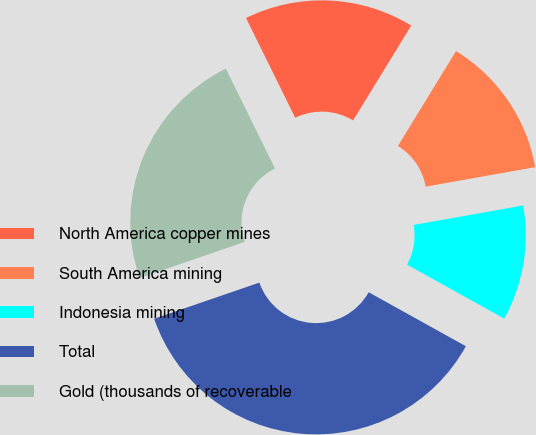Convert chart. <chart><loc_0><loc_0><loc_500><loc_500><pie_chart><fcel>North America copper mines<fcel>South America mining<fcel>Indonesia mining<fcel>Total<fcel>Gold (thousands of recoverable<nl><fcel>16.03%<fcel>13.45%<fcel>10.87%<fcel>36.66%<fcel>22.98%<nl></chart> 